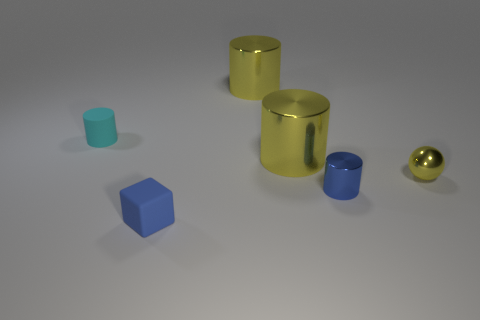Is the shape of the tiny cyan object the same as the tiny yellow thing?
Make the answer very short. No. How many tiny objects are blue cylinders or cyan objects?
Offer a terse response. 2. What color is the small matte cube?
Offer a very short reply. Blue. What is the shape of the small blue object to the left of the metallic thing that is in front of the tiny yellow object?
Offer a very short reply. Cube. Is there a red block that has the same material as the tiny blue cube?
Your answer should be compact. No. There is a cylinder behind the cyan object; is its size the same as the blue cylinder?
Make the answer very short. No. What number of purple things are tiny metallic cylinders or big metal cylinders?
Keep it short and to the point. 0. What is the material of the large thing behind the matte cylinder?
Your answer should be compact. Metal. What number of yellow metallic spheres are on the right side of the small rubber object on the left side of the small block?
Your answer should be compact. 1. What number of blue metal objects are the same shape as the small cyan object?
Keep it short and to the point. 1. 